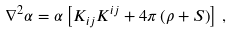Convert formula to latex. <formula><loc_0><loc_0><loc_500><loc_500>\nabla ^ { 2 } \alpha = \alpha \left [ K _ { i j } K ^ { i j } + 4 \pi \left ( \rho + S \right ) \right ] \, ,</formula> 